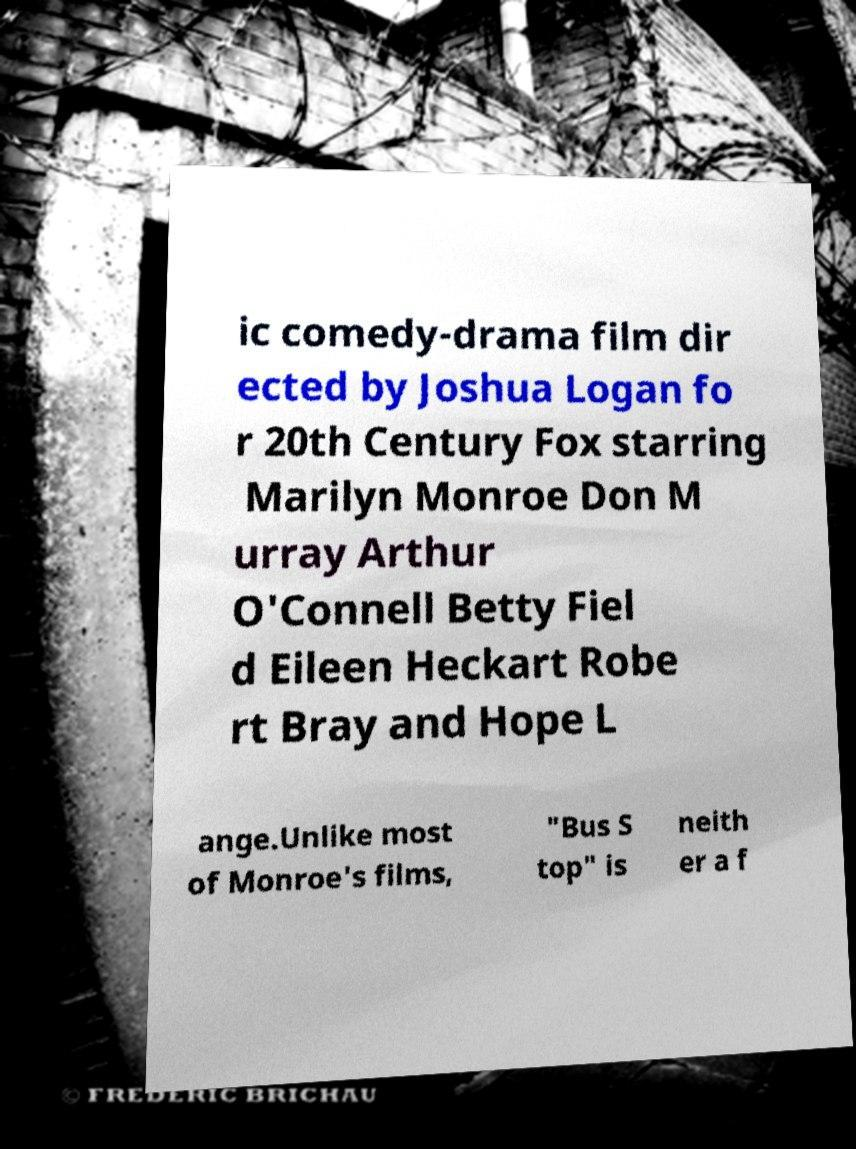Can you accurately transcribe the text from the provided image for me? ic comedy-drama film dir ected by Joshua Logan fo r 20th Century Fox starring Marilyn Monroe Don M urray Arthur O'Connell Betty Fiel d Eileen Heckart Robe rt Bray and Hope L ange.Unlike most of Monroe's films, "Bus S top" is neith er a f 